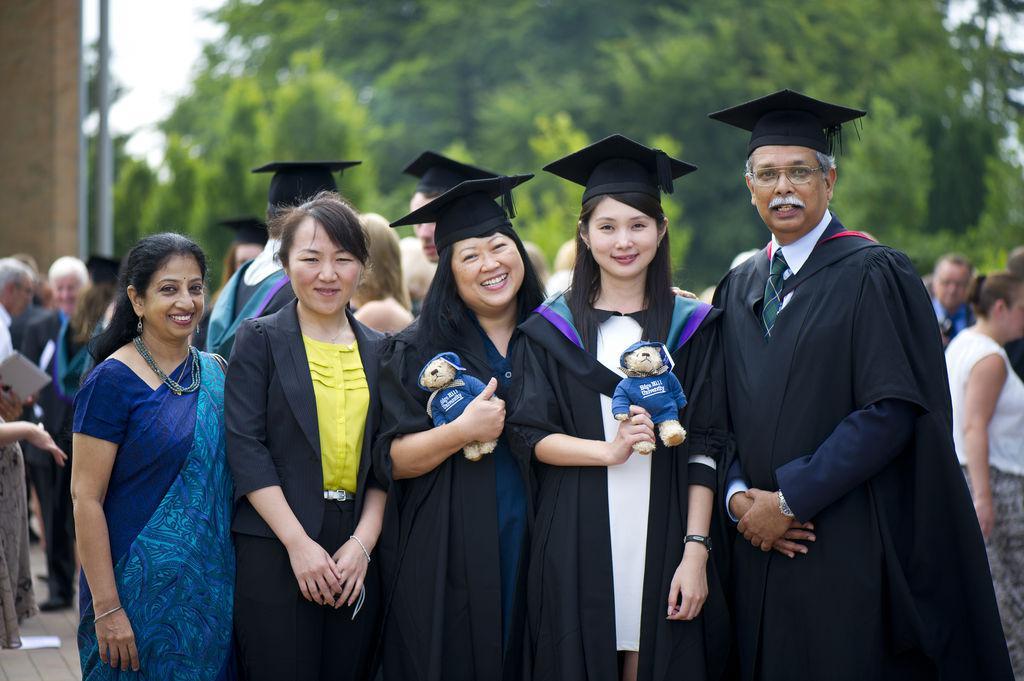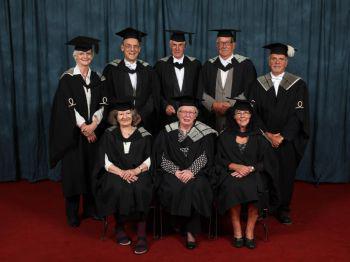The first image is the image on the left, the second image is the image on the right. For the images displayed, is the sentence "Two college graduates wearing black gowns and mortarboards are the focus of one image, while a single male wearing a gown is the focus of the second image." factually correct? Answer yes or no. No. The first image is the image on the left, the second image is the image on the right. For the images displayed, is the sentence "A single graduate is posing wearing a blue outfit in the image on the right." factually correct? Answer yes or no. No. 